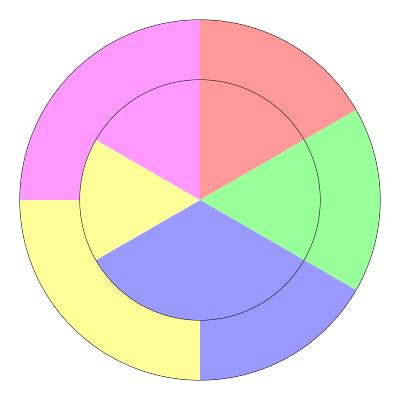In the nested donut chart representing demographic data, which age group shows the largest increase in proportion from the inner ring (current year) to the outer ring (projected future year)? To determine which age group shows the largest increase in proportion from the inner ring to the outer ring, we need to compare the angle of each segment in both rings:

1. Pink segment (top right):
   Inner: approximately 72° (20% of 360°)
   Outer: approximately 90° (25% of 360°)
   Increase: 18° (5%)

2. Green segment (right):
   Inner: approximately 72° (20% of 360°)
   Outer: approximately 90° (25% of 360°)
   Increase: 18° (5%)

3. Blue segment (bottom right):
   Inner: approximately 108° (30% of 360°)
   Outer: approximately 90° (25% of 360°)
   Decrease: 18° (5%)

4. Yellow segment (bottom left):
   Inner: approximately 72° (20% of 360°)
   Outer: approximately 90° (25% of 360°)
   Increase: 18° (5%)

5. Purple segment (top left):
   Inner: approximately 36° (10% of 360°)
   Outer: approximately 0° (0% of 360°)
   Decrease: 36° (10%)

The pink, green, and yellow segments all show an equal increase of 5% from the inner to the outer ring, which is the largest increase among all segments.
Answer: Pink, Green, and Yellow (tie) 